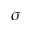<formula> <loc_0><loc_0><loc_500><loc_500>\sigma</formula> 